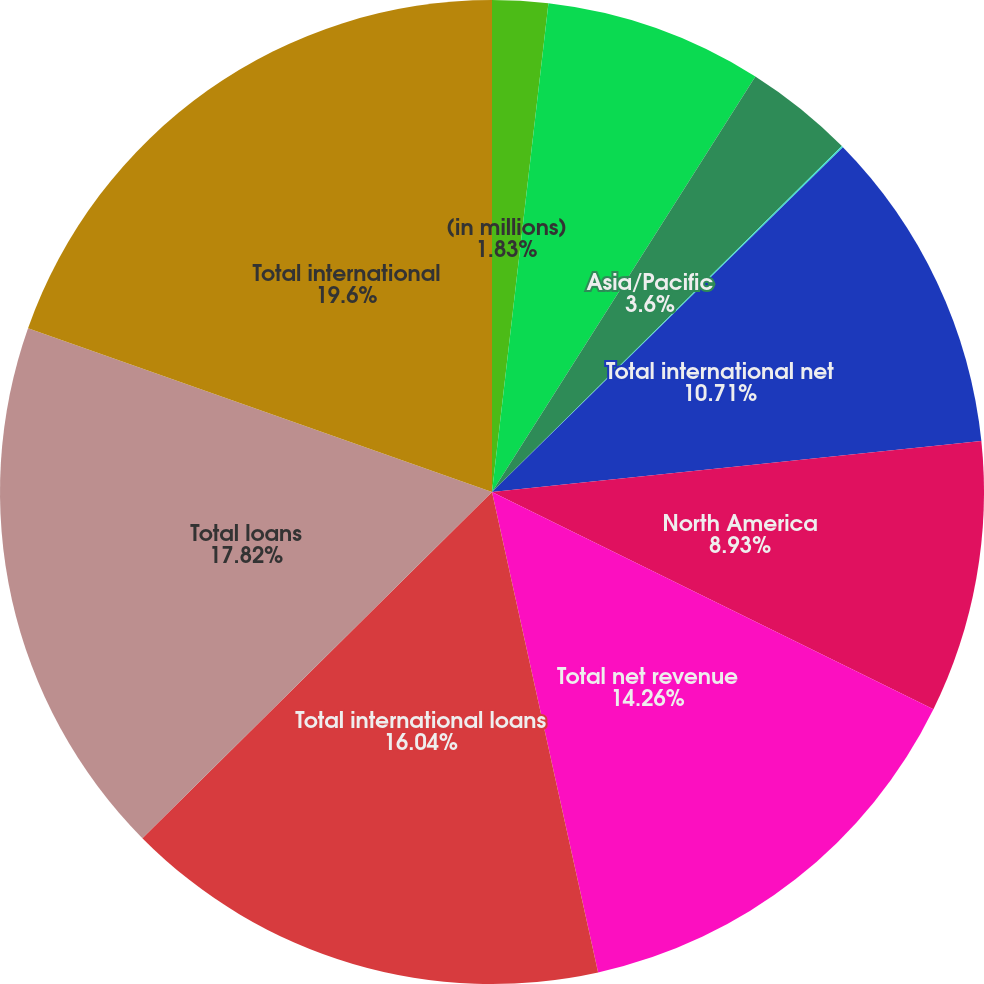Convert chart. <chart><loc_0><loc_0><loc_500><loc_500><pie_chart><fcel>(in millions)<fcel>Europe/Middle East/Africa<fcel>Asia/Pacific<fcel>Latin America/Caribbean<fcel>Total international net<fcel>North America<fcel>Total net revenue<fcel>Total international loans<fcel>Total loans<fcel>Total international<nl><fcel>1.83%<fcel>7.16%<fcel>3.6%<fcel>0.05%<fcel>10.71%<fcel>8.93%<fcel>14.26%<fcel>16.04%<fcel>17.82%<fcel>19.6%<nl></chart> 